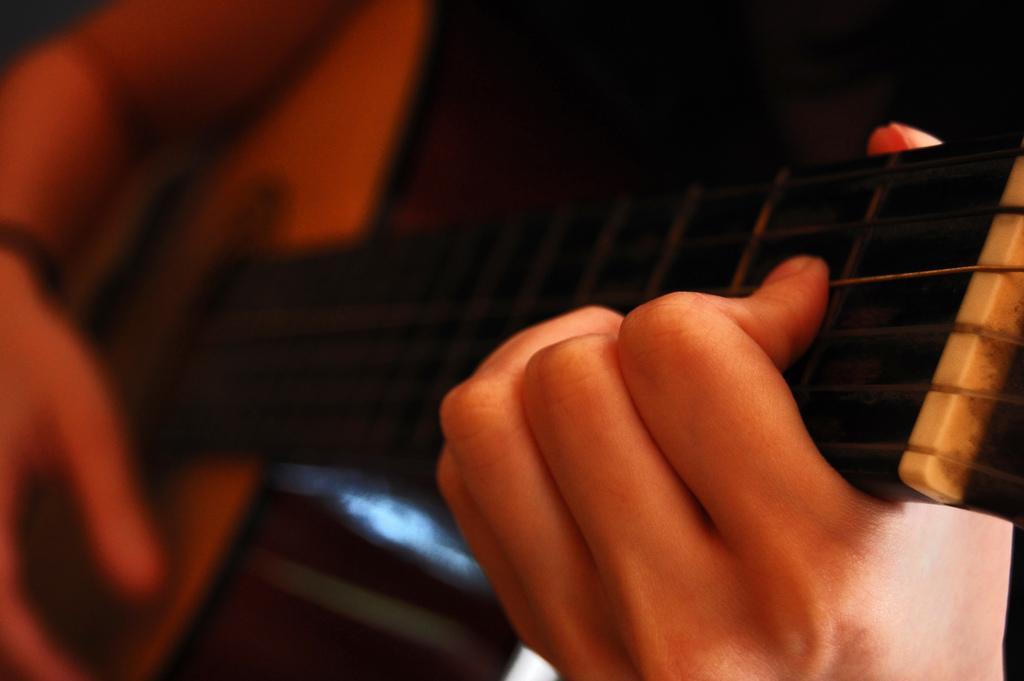In one or two sentences, can you explain what this image depicts? In the image we can see human hands holding guitar and the image is slightly blurred. 